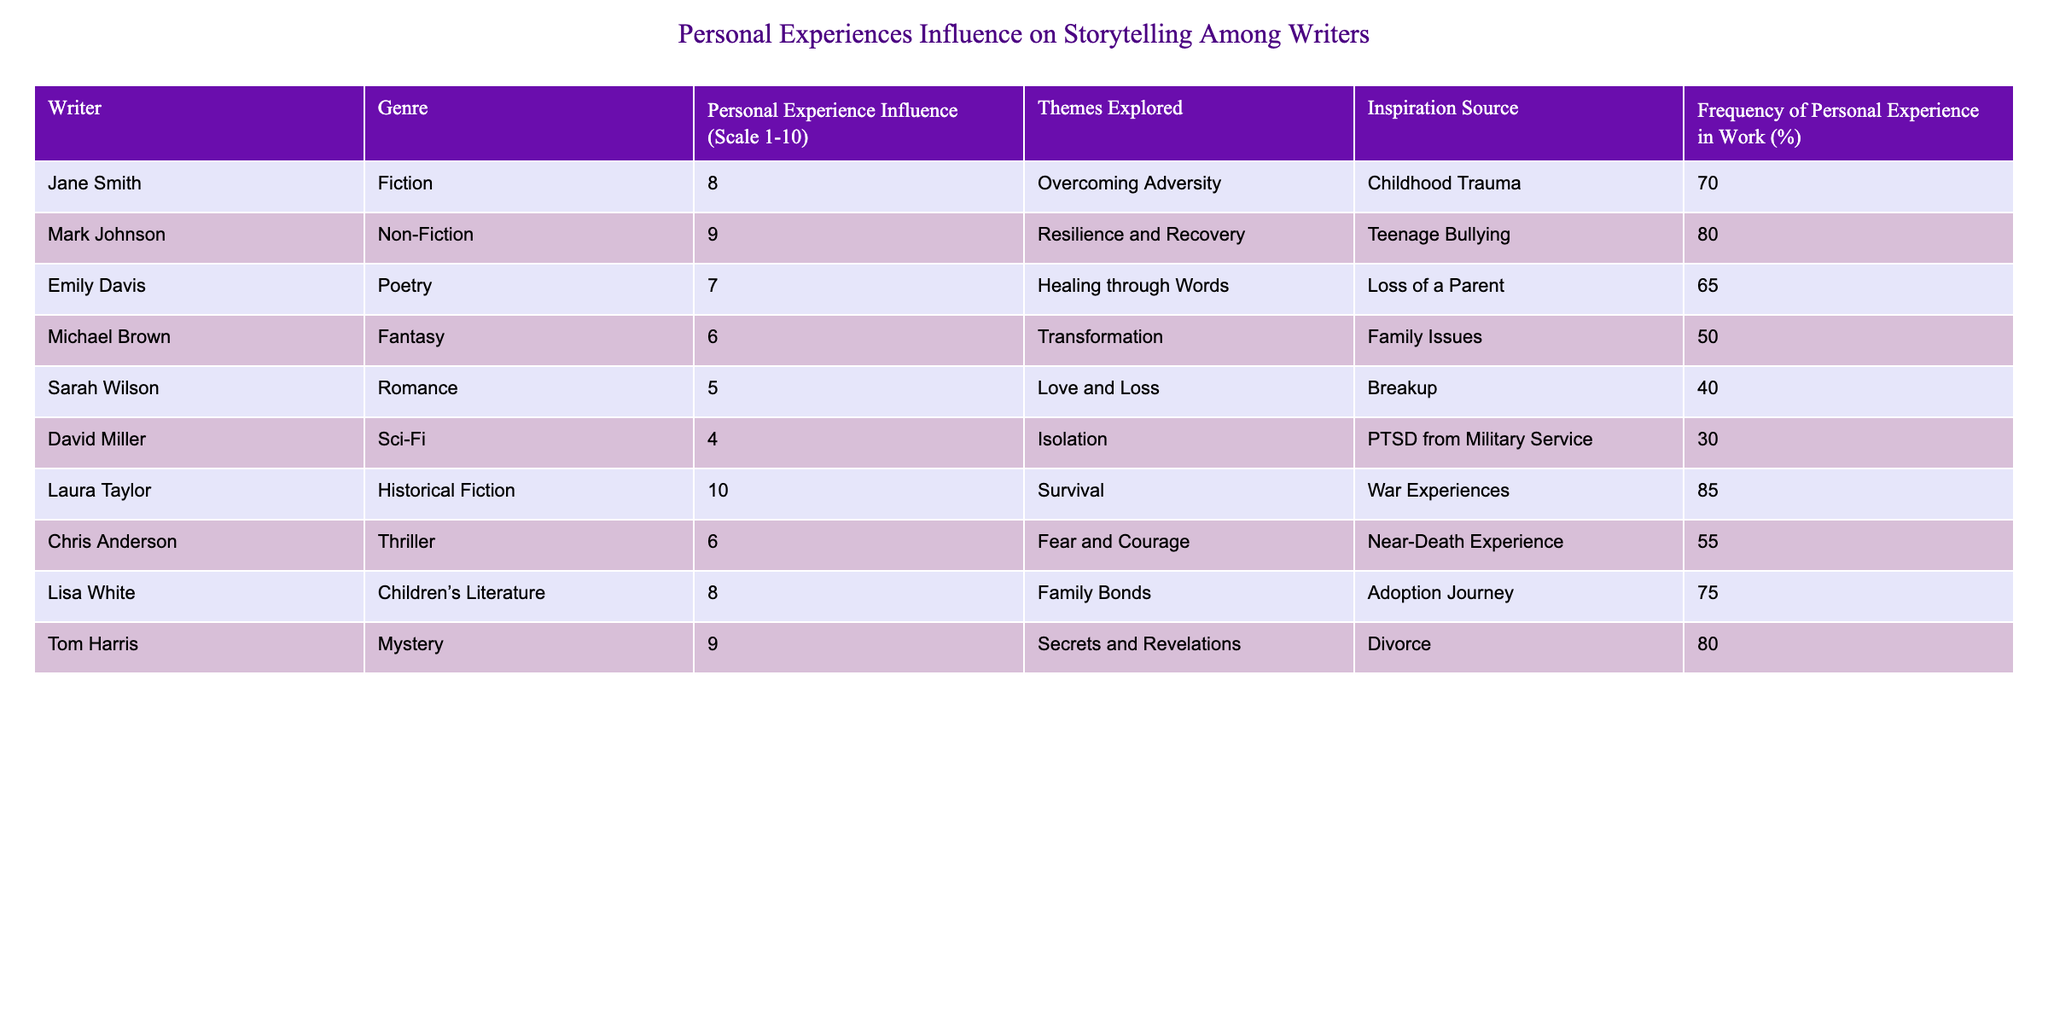What is the highest influence of personal experience on storytelling? The highest influence on the personal experience scale is 10, which corresponds to Laura Taylor in Historical Fiction.
Answer: 10 What percentage of writers include personal experiences in their work? To find the average percentage, we sum all the percentages (70 + 80 + 65 + 50 + 40 + 30 + 85 + 55 + 75 + 80 = 730) and divide by the number of writers (10). So, 730/10 = 73.
Answer: 73 Is there any writer whose influence score is less than 5? Yes, David Miller has a personal experience influence score of 4, which is less than 5.
Answer: Yes Which genre has the most significant personal experience influence and what is that score? Laura Taylor in Historical Fiction has the highest score of 10 for personal experience influence.
Answer: Historical Fiction, 10 What is the average personal experience influence of writers exploring themes of loss? The writers exploring loss are Emily Davis (7), Lisa White (8), and Sarah Wilson (5). Their average influence is (7 + 8 + 5) / 3 = 20 / 3 = 6.67.
Answer: 6.67 How many writers mentioned trauma as an inspiration source? The writers mentioning trauma sources are Jane Smith (Childhood Trauma), Mark Johnson (Teenage Bullying), and David Miller (PTSD from Military Service), totaling 3.
Answer: 3 Is the influence score for writers in Non-Fiction generally higher than those in Poetry? Mark Johnson in Non-Fiction has a score of 9, while Emily Davis in Poetry has a score of 7, indicating Non-Fiction writers generally have a higher influence score.
Answer: Yes What is the difference in frequency of personal experience used in work between the writer with the lowest and the highest frequency? Laura Taylor has the highest frequency at 85%, and David Miller has the lowest at 30%. The difference is 85% - 30% = 55%.
Answer: 55% 